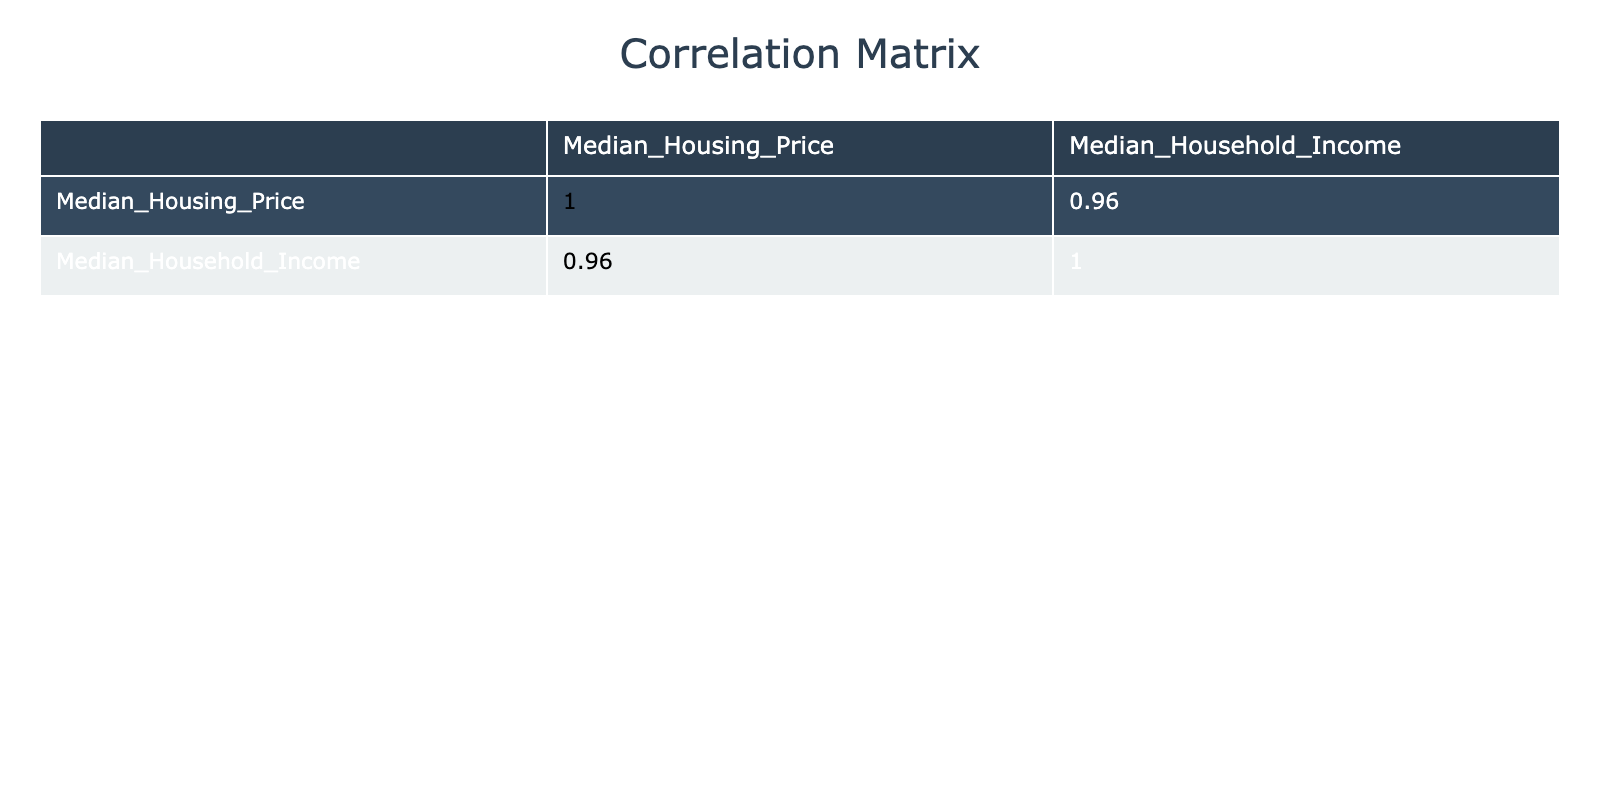What is the median household income in the Mission District? The table shows the values for each neighborhood. Looking at the Mission District row, the corresponding median household income is listed as 90,000.
Answer: 90,000 Which neighborhood has the highest median housing price? The highest value in the Median Housing Price column needs to be identified. Scanning through the table, Pacific Heights has the highest median housing price at 4,000,000.
Answer: Pacific Heights Is there a neighborhood where the median household income is above 100,000? By looking at the Median Household Income column, the neighborhoods Richmond District and Pacific Heights have incomes over 100,000. Therefore, the answer is yes.
Answer: Yes What is the difference between the median housing price in Pacific Heights and the median income in the Tenderloin? First, identify the median housing price in Pacific Heights, which is 4,000,000. Then, identify the median household income in the Tenderloin, which is 40,000. Subtract the latter from the former: 4,000,000 - 40,000 = 3,960,000.
Answer: 3,960,000 What is the average median household income for all neighborhoods in the table? Start by adding all the median household incomes together: 90,000 + 40,000 + 120,000 + 85,000 + 95,000 + 110,000 + 95,000 + 60,000 + 200,000 + 70,000 = 1,025,000. There are 10 neighborhoods, so the average income is 1,025,000 / 10 = 102,500.
Answer: 102,500 Are there any neighborhoods where the median housing price is below 1,000,000? Check the Median Housing Price column for any values below 1,000,000. The only neighborhood fitting this criterion is Bayview-Hunters Point at 600,000. Hence, yes, there are neighborhoods below 1,000,000.
Answer: Yes What is the median housing price in the Outer Sunset? The table directly provides information in the Outer Sunset row under the Median Housing Price column, which shows a value of 1,400,000.
Answer: 1,400,000 How many neighborhoods have a median household income less than 80,000? Review the Median Household Income column and count the neighborhoods with incomes lower than 80,000. Two neighborhoods—Tenderloin (40,000) and Chinatown (60,000)—fit this criteria. Thus, the total is 2.
Answer: 2 